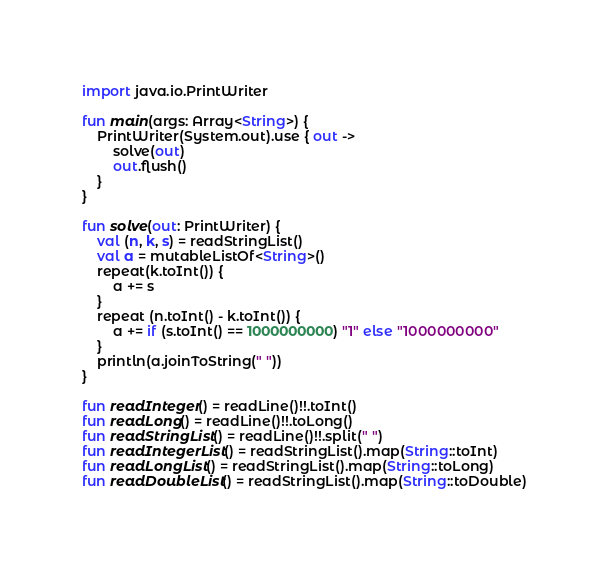Convert code to text. <code><loc_0><loc_0><loc_500><loc_500><_Kotlin_>import java.io.PrintWriter

fun main(args: Array<String>) {
    PrintWriter(System.out).use { out ->
        solve(out)
        out.flush()
    }
}

fun solve(out: PrintWriter) {
    val (n, k, s) = readStringList()
    val a = mutableListOf<String>()
    repeat(k.toInt()) {
        a += s
    }
    repeat (n.toInt() - k.toInt()) {
        a += if (s.toInt() == 1000000000) "1" else "1000000000"
    }
    println(a.joinToString(" "))
}

fun readInteger() = readLine()!!.toInt()
fun readLong() = readLine()!!.toLong()
fun readStringList() = readLine()!!.split(" ")
fun readIntegerList() = readStringList().map(String::toInt)
fun readLongList() = readStringList().map(String::toLong)
fun readDoubleList() = readStringList().map(String::toDouble)
</code> 